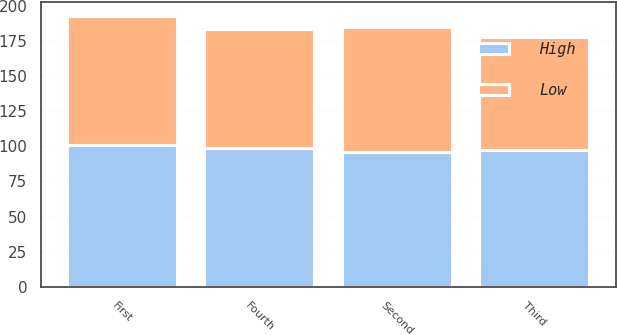Convert chart. <chart><loc_0><loc_0><loc_500><loc_500><stacked_bar_chart><ecel><fcel>First<fcel>Second<fcel>Third<fcel>Fourth<nl><fcel>High<fcel>100.9<fcel>95.87<fcel>97.65<fcel>98.63<nl><fcel>Low<fcel>91.93<fcel>88.88<fcel>79.86<fcel>84.71<nl></chart> 